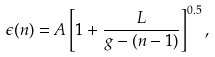Convert formula to latex. <formula><loc_0><loc_0><loc_500><loc_500>\epsilon ( n ) = A \left [ 1 + \frac { L } { g - ( n - 1 ) } \right ] ^ { 0 . 5 } ,</formula> 